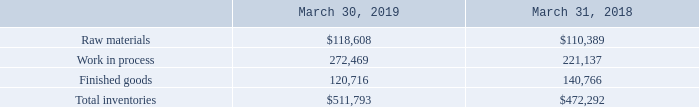4. INVENTORIES
The components of inventories, net, are as follows (in thousands):
What are the respective values of the company's raw materials on March 31, 2018 and 2019?
Answer scale should be: thousand. $110,389, $118,608. What are the respective values of the company's work in process inventories on March 31, 2018 and 2019?
Answer scale should be: thousand. 221,137, 272,469. What are the respective values of the company's finished goods on March 31, 2018 and 2019?
Answer scale should be: thousand. 140,766, 120,716. What is the change in the company's raw materials on March 31, 2018 and 2019?
Answer scale should be: thousand. $118,608 - $110,389 
Answer: 8219. What is the average value of the company's raw materials on March 31, 2018 and 2019?
Answer scale should be: thousand. ($110,389 + $118,608)/2 
Answer: 114498.5. What is the average value of the company's finished goods on March 31, 2018 and 2019?
Answer scale should be: thousand. (140,766 + 120,716)/2 
Answer: 130741. 